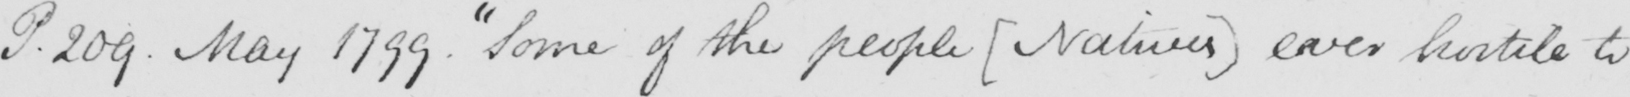What text is written in this handwritten line? P.209 . May 1799 .  " Some of the people  ( Natives )  ever hostile to 